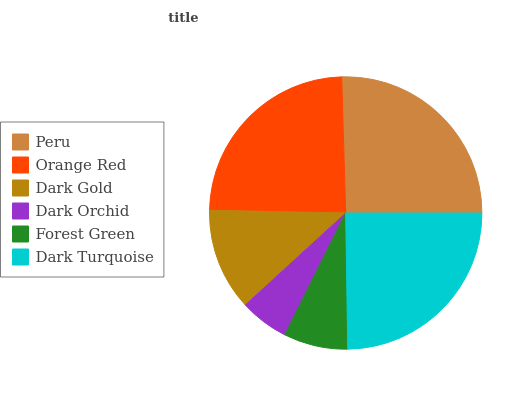Is Dark Orchid the minimum?
Answer yes or no. Yes. Is Peru the maximum?
Answer yes or no. Yes. Is Orange Red the minimum?
Answer yes or no. No. Is Orange Red the maximum?
Answer yes or no. No. Is Peru greater than Orange Red?
Answer yes or no. Yes. Is Orange Red less than Peru?
Answer yes or no. Yes. Is Orange Red greater than Peru?
Answer yes or no. No. Is Peru less than Orange Red?
Answer yes or no. No. Is Orange Red the high median?
Answer yes or no. Yes. Is Dark Gold the low median?
Answer yes or no. Yes. Is Dark Turquoise the high median?
Answer yes or no. No. Is Dark Orchid the low median?
Answer yes or no. No. 